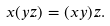<formula> <loc_0><loc_0><loc_500><loc_500>x ( y z ) = ( x y ) z .</formula> 